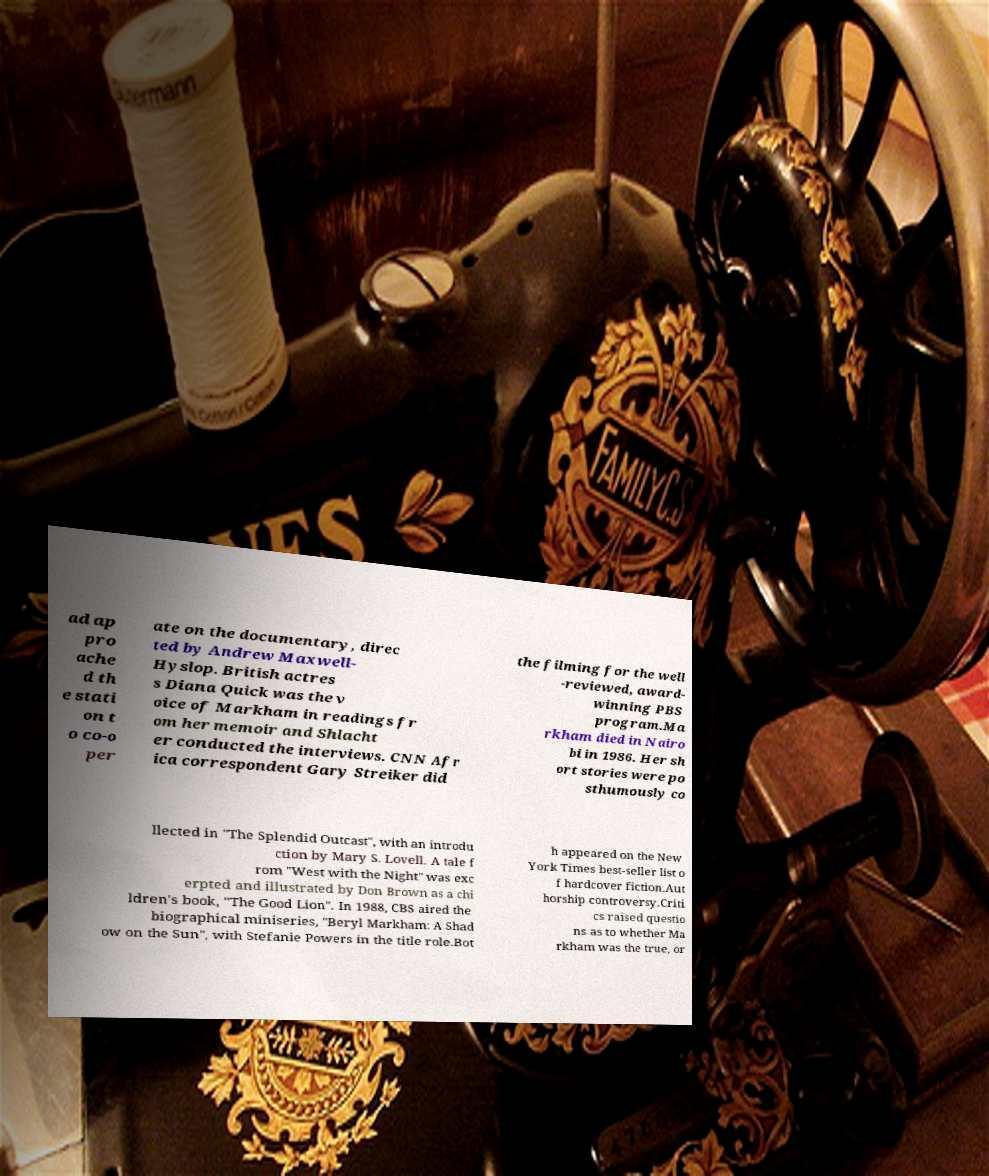What messages or text are displayed in this image? I need them in a readable, typed format. ad ap pro ache d th e stati on t o co-o per ate on the documentary, direc ted by Andrew Maxwell- Hyslop. British actres s Diana Quick was the v oice of Markham in readings fr om her memoir and Shlacht er conducted the interviews. CNN Afr ica correspondent Gary Streiker did the filming for the well -reviewed, award- winning PBS program.Ma rkham died in Nairo bi in 1986. Her sh ort stories were po sthumously co llected in "The Splendid Outcast", with an introdu ction by Mary S. Lovell. A tale f rom "West with the Night" was exc erpted and illustrated by Don Brown as a chi ldren's book, "The Good Lion". In 1988, CBS aired the biographical miniseries, "Beryl Markham: A Shad ow on the Sun", with Stefanie Powers in the title role.Bot h appeared on the New York Times best-seller list o f hardcover fiction.Aut horship controversy.Criti cs raised questio ns as to whether Ma rkham was the true, or 